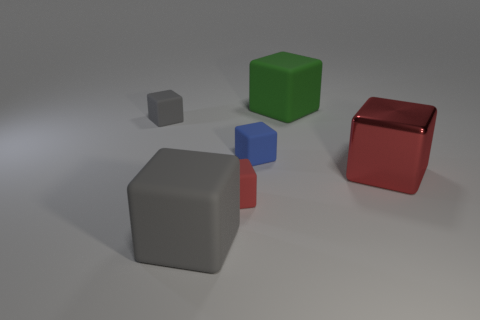Is there a tiny brown metal cylinder?
Your response must be concise. No. There is a red thing on the left side of the large green rubber block; is it the same size as the red object on the right side of the big green rubber object?
Your answer should be very brief. No. What is the material of the large cube that is in front of the green thing and behind the tiny red rubber object?
Your answer should be very brief. Metal. What number of tiny matte blocks are right of the tiny gray matte cube?
Your response must be concise. 2. Is there anything else that has the same size as the red metallic thing?
Your answer should be very brief. Yes. There is another big cube that is made of the same material as the large green cube; what is its color?
Your answer should be very brief. Gray. Is the big red object the same shape as the small blue object?
Your answer should be compact. Yes. What number of large blocks are both left of the small red rubber object and behind the big red block?
Offer a terse response. 0. What number of matte objects are either small gray cubes or big gray cubes?
Give a very brief answer. 2. There is a red thing in front of the metallic cube in front of the large green matte thing; how big is it?
Offer a very short reply. Small. 